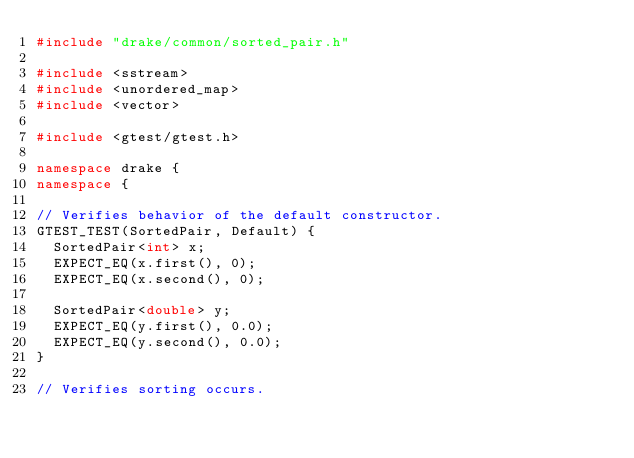Convert code to text. <code><loc_0><loc_0><loc_500><loc_500><_C++_>#include "drake/common/sorted_pair.h"

#include <sstream>
#include <unordered_map>
#include <vector>

#include <gtest/gtest.h>

namespace drake {
namespace {

// Verifies behavior of the default constructor.
GTEST_TEST(SortedPair, Default) {
  SortedPair<int> x;
  EXPECT_EQ(x.first(), 0);
  EXPECT_EQ(x.second(), 0);

  SortedPair<double> y;
  EXPECT_EQ(y.first(), 0.0);
  EXPECT_EQ(y.second(), 0.0);
}

// Verifies sorting occurs.</code> 